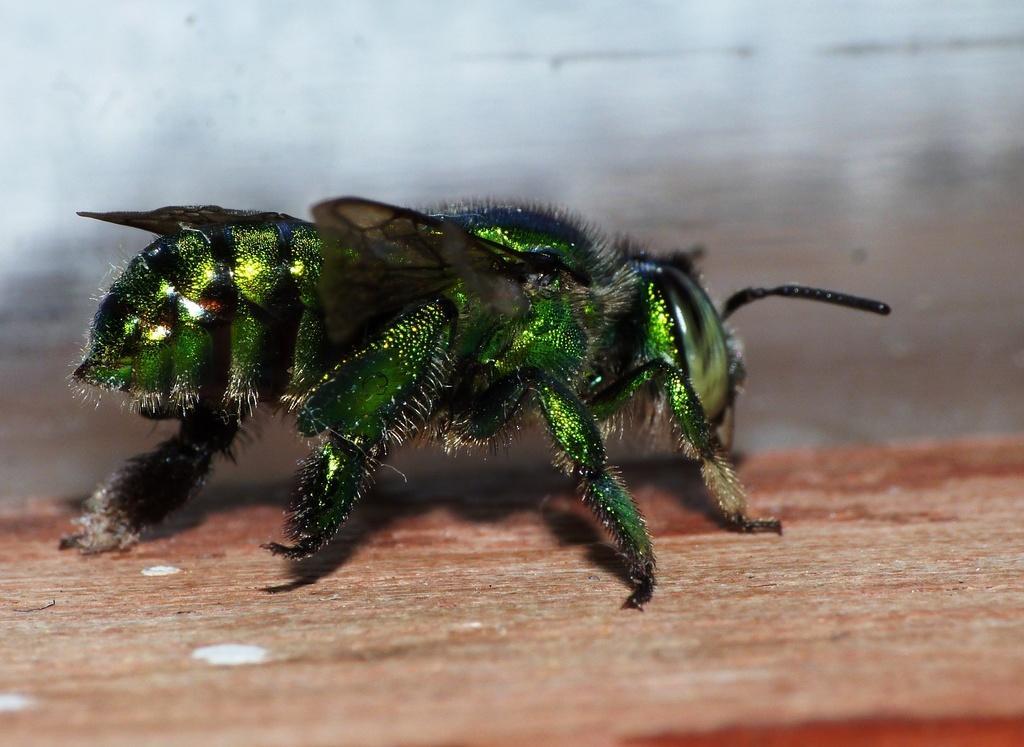Could you give a brief overview of what you see in this image? In the foreground of this image, there is a green insect on the wooden surface and the background image is blur. 